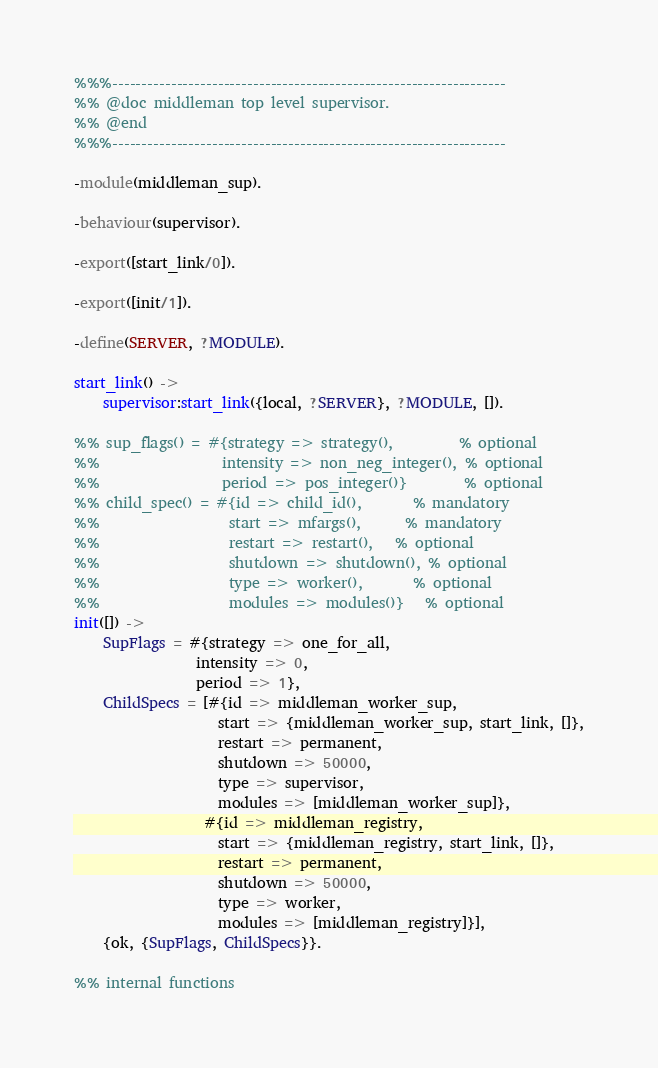Convert code to text. <code><loc_0><loc_0><loc_500><loc_500><_Erlang_>%%%-------------------------------------------------------------------
%% @doc middleman top level supervisor.
%% @end
%%%-------------------------------------------------------------------

-module(middleman_sup).

-behaviour(supervisor).

-export([start_link/0]).

-export([init/1]).

-define(SERVER, ?MODULE).

start_link() ->
    supervisor:start_link({local, ?SERVER}, ?MODULE, []).

%% sup_flags() = #{strategy => strategy(),         % optional
%%                 intensity => non_neg_integer(), % optional
%%                 period => pos_integer()}        % optional
%% child_spec() = #{id => child_id(),       % mandatory
%%                  start => mfargs(),      % mandatory
%%                  restart => restart(),   % optional
%%                  shutdown => shutdown(), % optional
%%                  type => worker(),       % optional
%%                  modules => modules()}   % optional
init([]) ->
    SupFlags = #{strategy => one_for_all,
                 intensity => 0,
                 period => 1},
    ChildSpecs = [#{id => middleman_worker_sup,
                    start => {middleman_worker_sup, start_link, []},
                    restart => permanent,
                    shutdown => 50000,
                    type => supervisor,
                    modules => [middleman_worker_sup]},
                  #{id => middleman_registry,
                    start => {middleman_registry, start_link, []},
                    restart => permanent,
                    shutdown => 50000,
                    type => worker,
                    modules => [middleman_registry]}],
    {ok, {SupFlags, ChildSpecs}}.

%% internal functions
</code> 